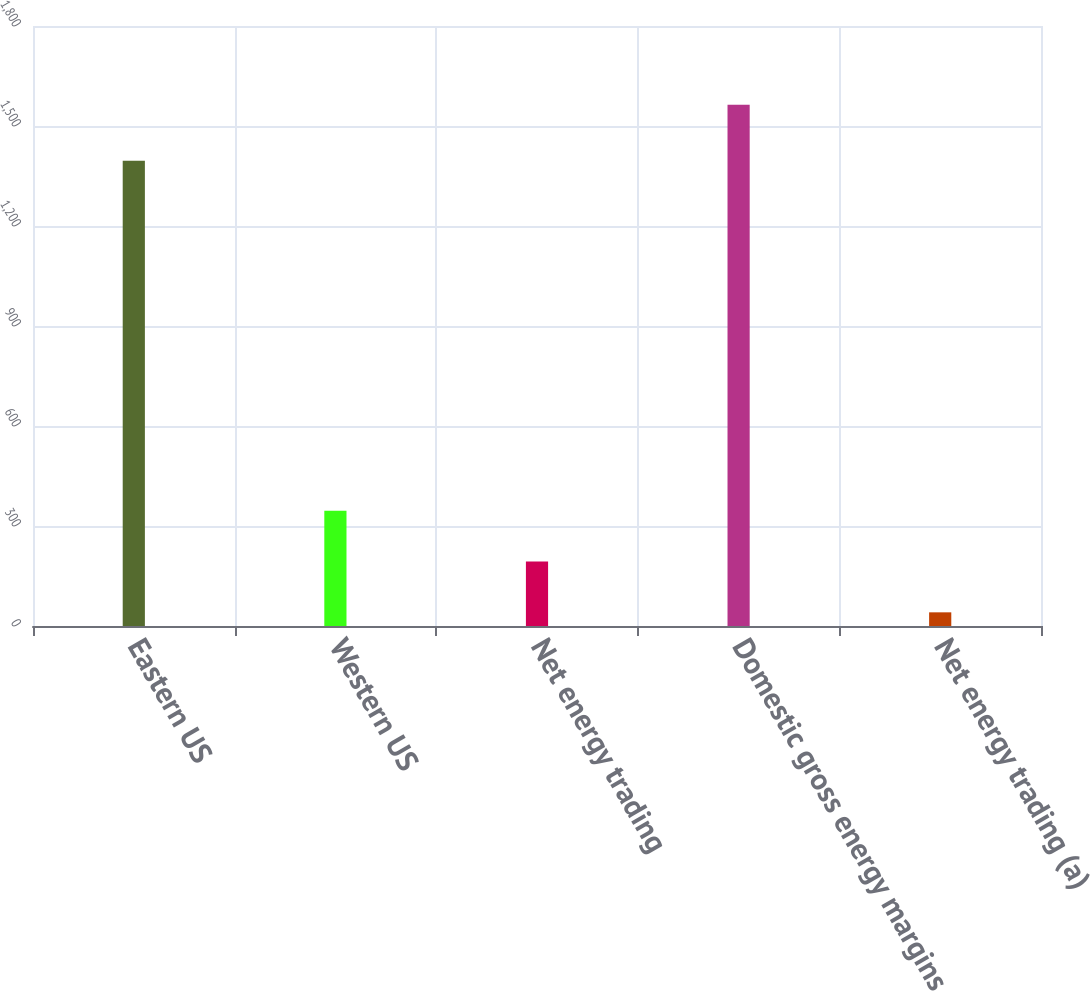<chart> <loc_0><loc_0><loc_500><loc_500><bar_chart><fcel>Eastern US<fcel>Western US<fcel>Net energy trading<fcel>Domestic gross energy margins<fcel>Net energy trading (a)<nl><fcel>1396<fcel>345.6<fcel>193.3<fcel>1564<fcel>41<nl></chart> 